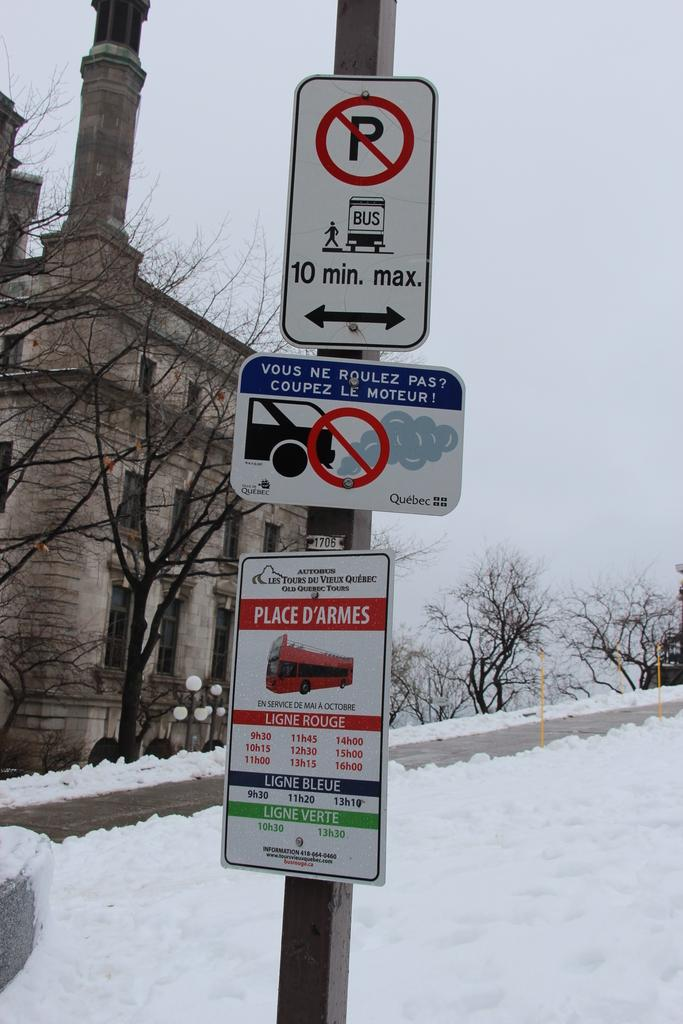<image>
Render a clear and concise summary of the photo. several signs on a snowy road read Place D'Armes bus 